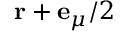<formula> <loc_0><loc_0><loc_500><loc_500>r + e _ { \mu } / 2</formula> 